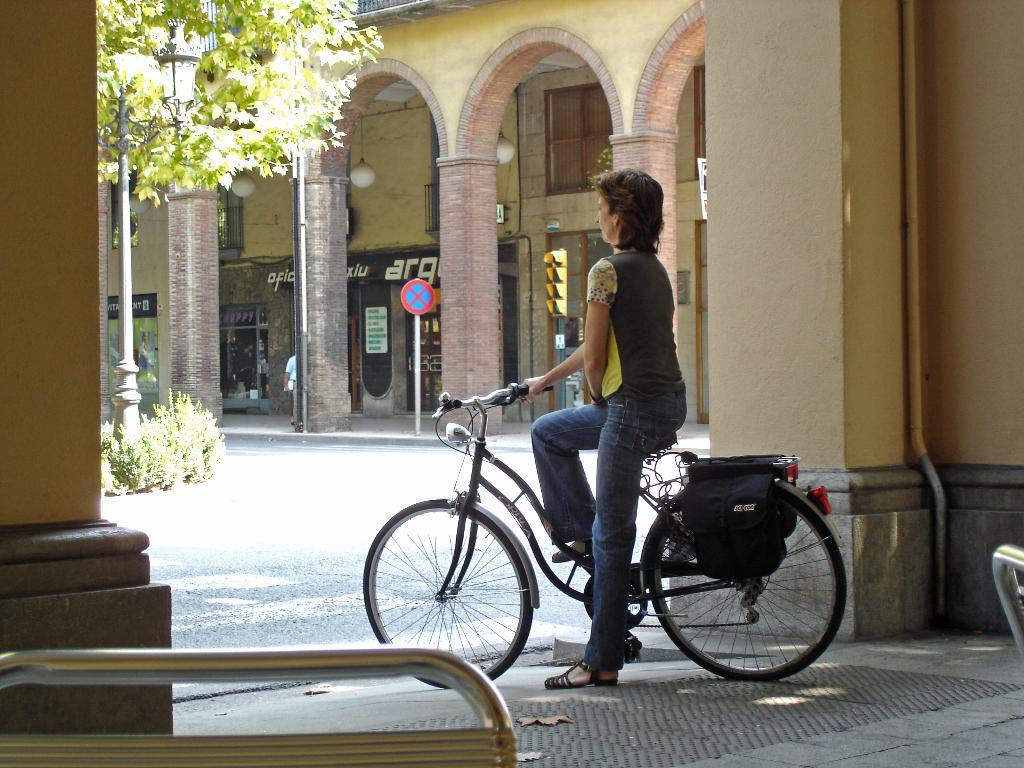What is the main subject of the image? The main subject of the image is a woman. What is the woman doing in the image? The woman is sitting on a bicycle. What is the woman looking at in the image? The woman is looking at something, but it is not specified in the facts. Can you describe the background of the image? In the background of the image, there is a pillar, a sign board, a pipe, a building, a window, a tree, and a pole. What type of party is being held in the image? There is no indication of a party in the image. What kind of plate is being used by the woman in the image? There is no plate visible in the image. 